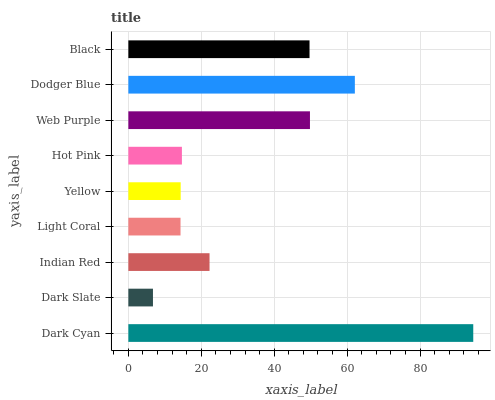Is Dark Slate the minimum?
Answer yes or no. Yes. Is Dark Cyan the maximum?
Answer yes or no. Yes. Is Indian Red the minimum?
Answer yes or no. No. Is Indian Red the maximum?
Answer yes or no. No. Is Indian Red greater than Dark Slate?
Answer yes or no. Yes. Is Dark Slate less than Indian Red?
Answer yes or no. Yes. Is Dark Slate greater than Indian Red?
Answer yes or no. No. Is Indian Red less than Dark Slate?
Answer yes or no. No. Is Indian Red the high median?
Answer yes or no. Yes. Is Indian Red the low median?
Answer yes or no. Yes. Is Yellow the high median?
Answer yes or no. No. Is Yellow the low median?
Answer yes or no. No. 